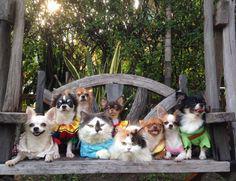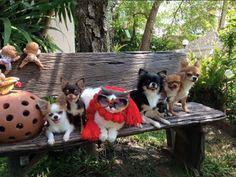The first image is the image on the left, the second image is the image on the right. For the images displayed, is the sentence "In at least one of the images, six dogs are posing for a picture, while on a bench." factually correct? Answer yes or no. Yes. The first image is the image on the left, the second image is the image on the right. Given the left and right images, does the statement "Each image shows a row of dressed dogs posing with a cat that is also wearing some garment." hold true? Answer yes or no. Yes. 